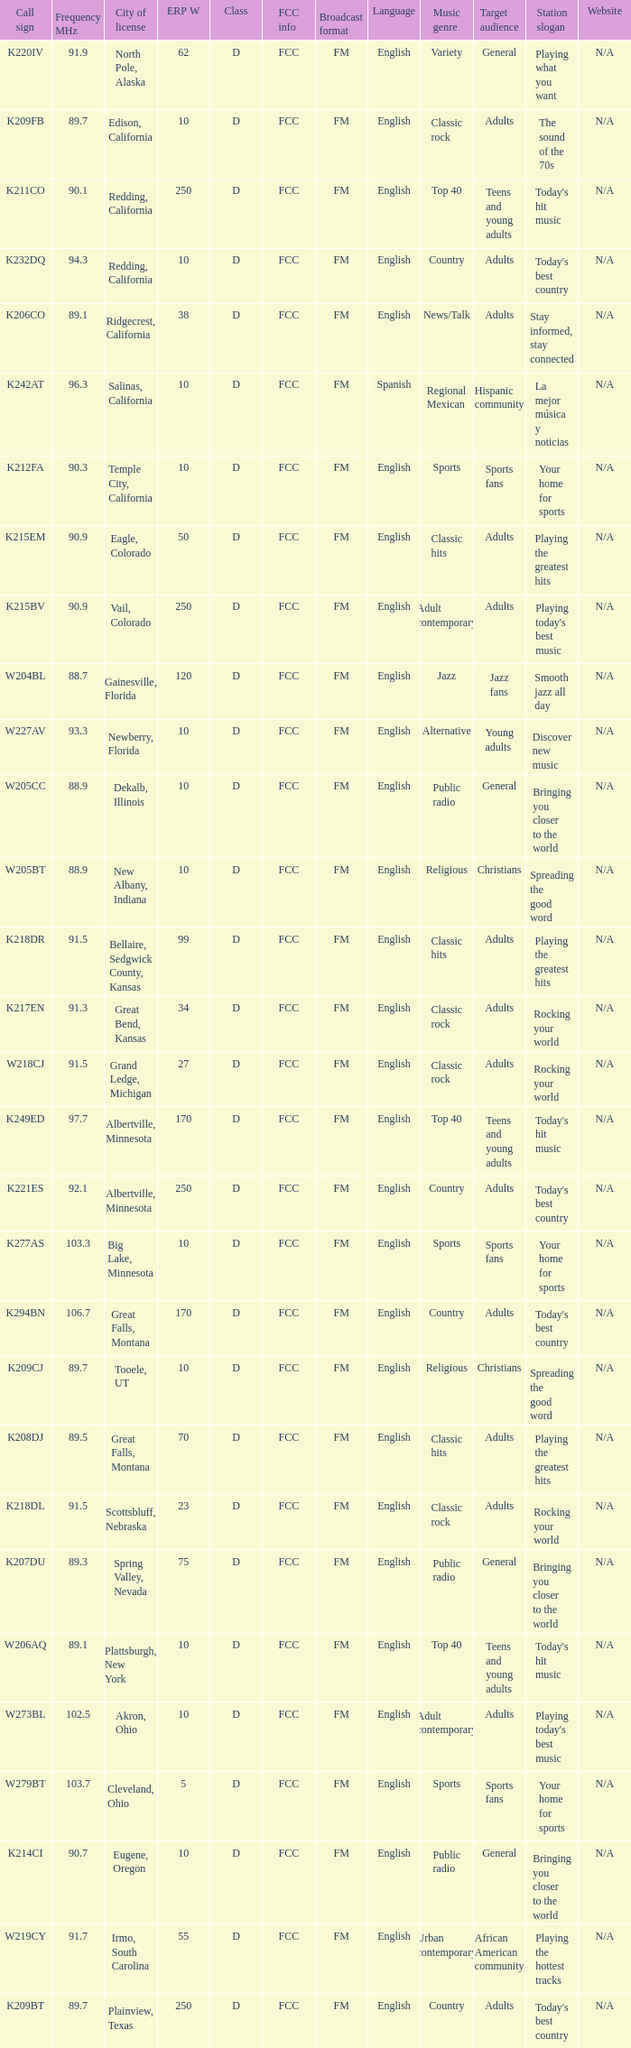What is the FCC info of the translator with an Irmo, South Carolina city license? FCC. 